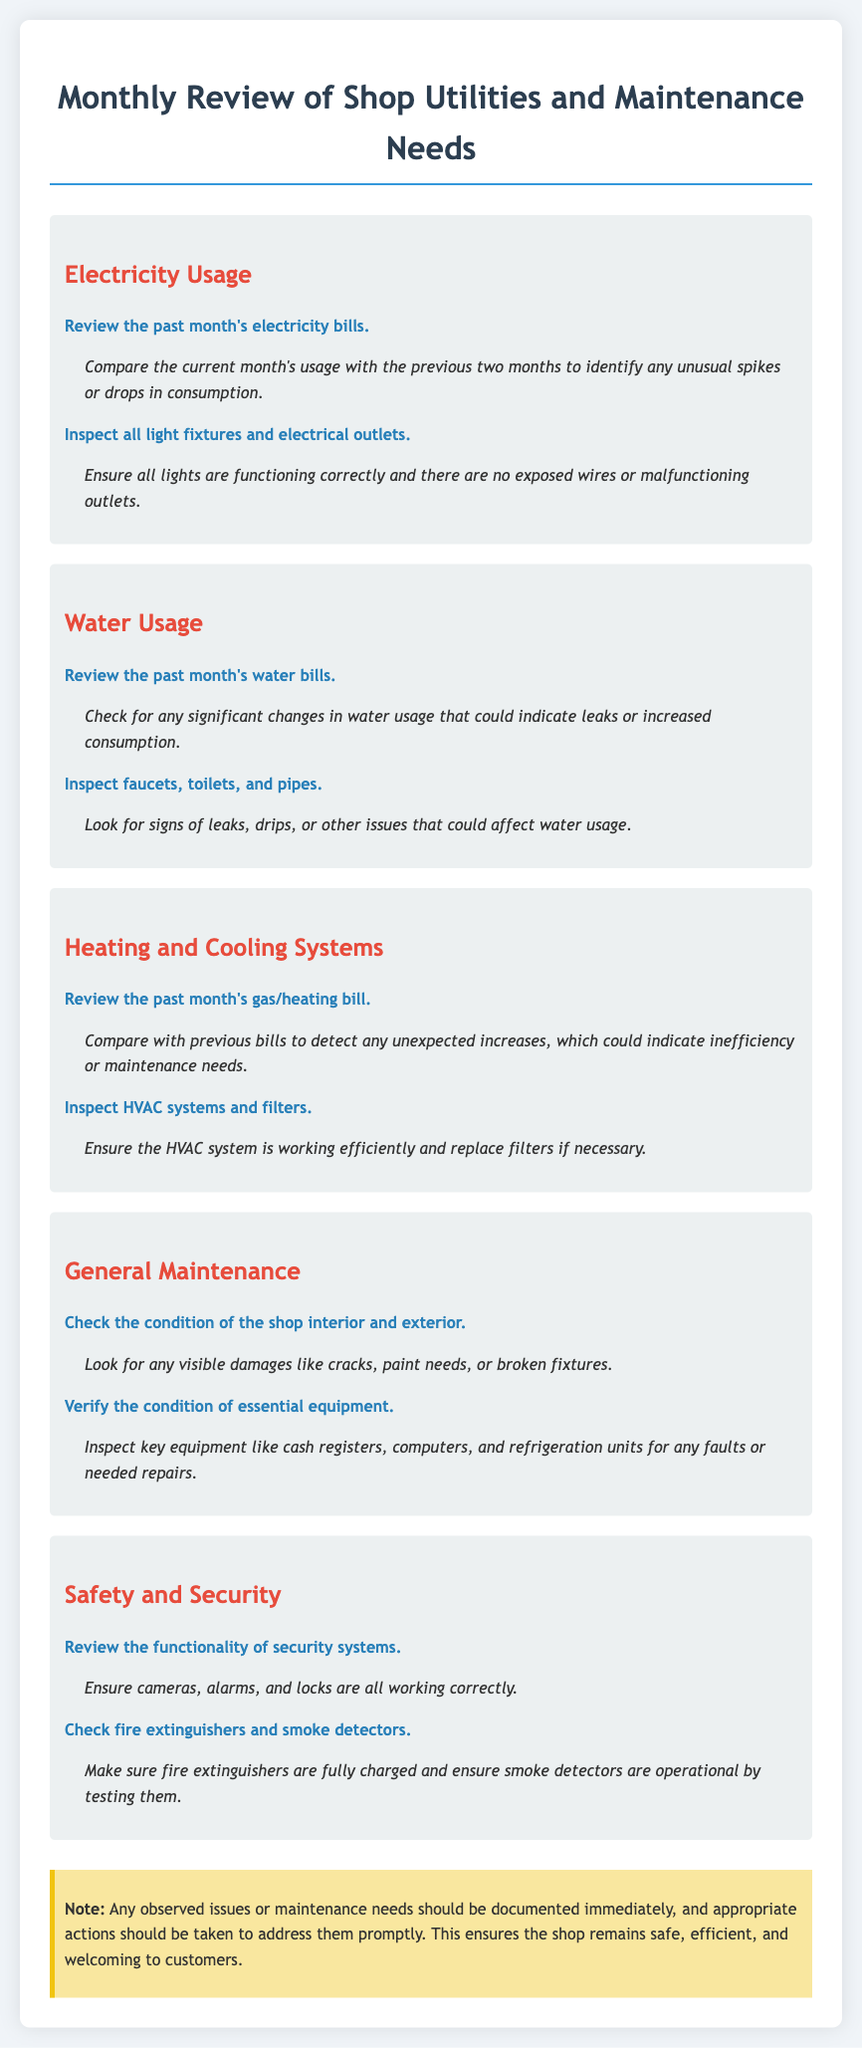what is the title of the document? The title is mentioned at the beginning of the document and provides a clear indication of its content.
Answer: Monthly Review of Shop Utilities and Maintenance Needs how many sections are there in the document? The document contains multiple sections, each covering different maintenance aspects related to the shop.
Answer: 5 what is the first item listed under Electricity Usage? The first item is the description of what to review in relation to electricity usage for the month.
Answer: Review the past month's electricity bills what should be inspected under Water Usage? The document specifies multiple items for inspection regarding water usage and issues that could arise.
Answer: Faucets, toilets, and pipes what should be done to the HVAC system? The document outlines an important maintenance task for HVAC systems which is crucial for shop operation.
Answer: Inspect HVAC systems and filters which systems' functionality should be reviewed for safety? The document highlights the importance of security checks related to the shop environment and customer's safety.
Answer: Security systems how should fire extinguishers be checked? The document provides clear instructions for ensuring fire safety in the shop environment.
Answer: Fully charged what is a condition that needs to be checked under General Maintenance? The document specifies essential checks for both the interior and exterior of the shop to ensure upkeep.
Answer: Visible damages like cracks what is emphasized in the note at the end of the document? The note provides guidance on how to handle maintenance issues observed during the review process.
Answer: Documented immediately 